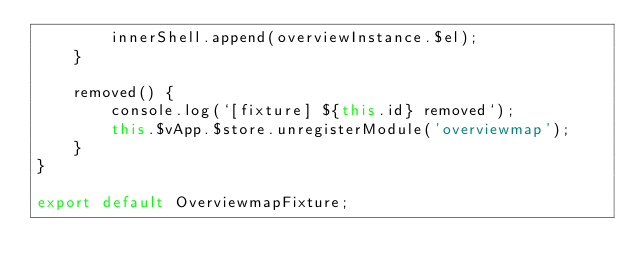Convert code to text. <code><loc_0><loc_0><loc_500><loc_500><_TypeScript_>        innerShell.append(overviewInstance.$el);
    }

    removed() {
        console.log(`[fixture] ${this.id} removed`);
        this.$vApp.$store.unregisterModule('overviewmap');
    }
}

export default OverviewmapFixture;
</code> 